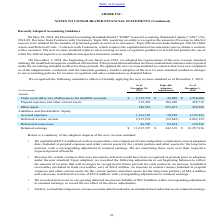From Adobe Systems's financial document, What does topic 606 require a company to do? The document shows two values: requiring an entity to recognize the amount of revenue to which it expects to be entitled for the transfer of promised goods or services to customers. and requires the capitalization of incremental costs to obtain a contract with a customer.. From the document: "Revenue from Contracts with Customers, Topic 606, requiring an entity to recognize the amount of revenue to which it expects to be entitled for the tr..." Also, When did the company adopt the new revenue standard requirements? According to the financial document, December 1, 2018. The relevant text states: "On December 1, 2018, the beginning of our fiscal year 2019, we adopted the requirements of the new revenue standard..." Also, can you calculate: How much was the Trade receivables, net of allowances for doubtful accounts changed by Topic 606? Based on the calculation: 43,028/1,315,578 , the result is 3.27 (percentage). This is based on the information: "vables, net of allowances for doubtful accounts $ 1,315,578 $ 43,028 $ 1,358,606 of allowances for doubtful accounts $ 1,315,578 $ 43,028 $ 1,358,606..." The key data points involved are: 1,315,578, 43,028. Also, can you calculate: What is the total assets as of November 30 2018? Based on the calculation: 1,315,578 + 312,499 + 186,522, the result is 1814599 (in thousands). This is based on the information: "Other assets 186,522 273,421 459,943 Prepaid expenses and other current assets 312,499 186,220 498,719 vables, net of allowances for doubtful accounts $ 1,315,578 $ 43,028 $ 1,358,606..." The key data points involved are: 1,315,578, 186,522, 312,499. Also, What is the value of capitalised contract acquisition costs? According to the financial document, $413.2 million. The relevant text states: "• We capitalized $413.2 million of contract acquisition costs comprised of sales and partner commission costs at adoption date (incl..." Also, can you calculate: After the Topic 606 adjustments, what is the percentage change in deferred revenue, current?  To answer this question, I need to perform calculations using the financial data. The calculation is: -52,842/2,863,132 , which equals -1.85 (percentage). This is based on the information: "Deferred revenue, current 2,915,974 (52,842) 2,863,132 Deferred revenue, current 2,915,974 (52,842) 2,863,132..." The key data points involved are: 2,863,132, 52,842. 